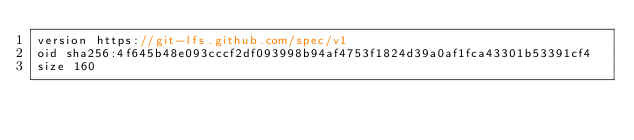<code> <loc_0><loc_0><loc_500><loc_500><_C#_>version https://git-lfs.github.com/spec/v1
oid sha256:4f645b48e093cccf2df093998b94af4753f1824d39a0af1fca43301b53391cf4
size 160
</code> 